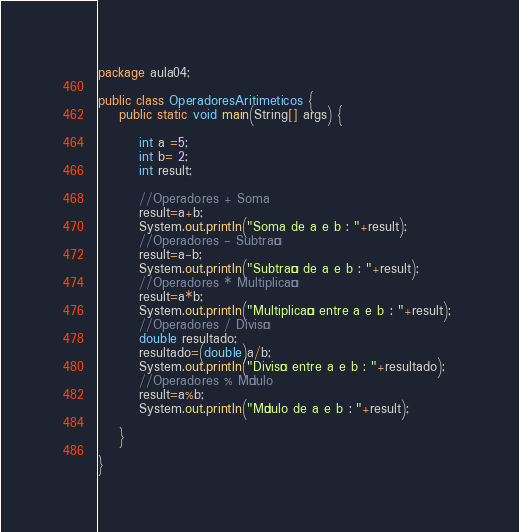Convert code to text. <code><loc_0><loc_0><loc_500><loc_500><_Java_>
package aula04;

public class OperadoresAritimeticos {
    public static void main(String[] args) {
       
        int a =5;
        int b= 2;
        int result;
        
        //Operadores + Soma  
        result=a+b;
        System.out.println("Soma de a e b : "+result);
        //Operadores - Subtração
        result=a-b;
        System.out.println("Subtração de a e b : "+result);
        //Operadores * Multiplicação
        result=a*b;
        System.out.println("Multiplicação entre a e b : "+result); 
        //Operadores / Divisão
        double resultado;
        resultado=(double)a/b;
        System.out.println("Divisão entre a e b : "+resultado);
        //Operadores % Módulo
        result=a%b;
        System.out.println("Módulo de a e b : "+result);
          
    }
 
}
</code> 